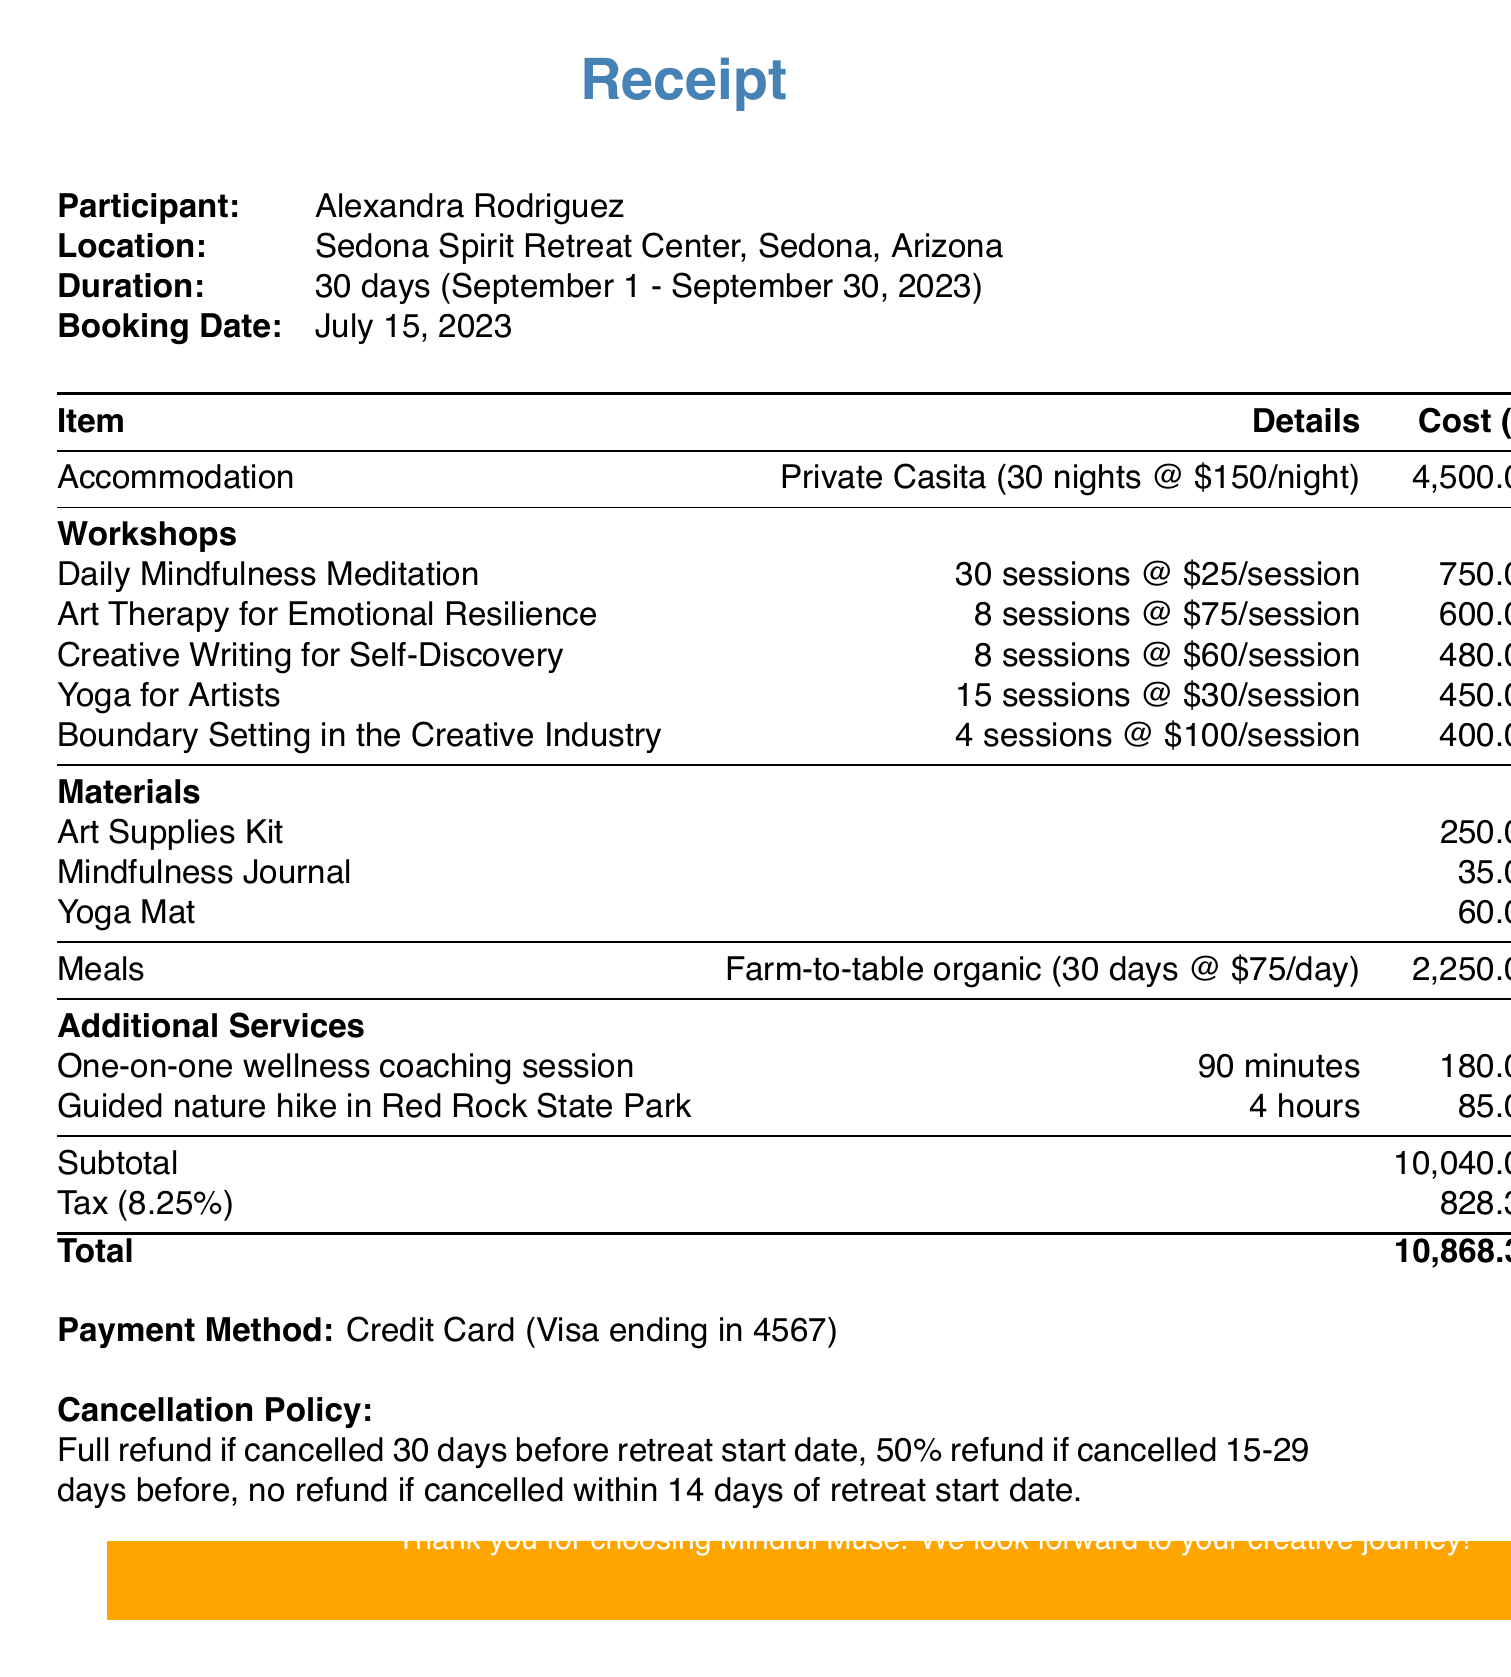What is the name of the retreat? The name of the retreat is listed at the top of the receipt, which is "Mindful Muse: Creative Rejuvenation Retreat."
Answer: Mindful Muse: Creative Rejuvenation Retreat Who is the participant? The participant's name is provided in the document, which is "Alexandra Rodriguez."
Answer: Alexandra Rodriguez What is the total cost of accommodation? The total cost of accommodation for the retreat is detailed in the receipt as "$4,500.00."
Answer: 4500.00 How many sessions are included in the Daily Mindfulness Meditation workshop? The document lists that there are "30 sessions" for the Daily Mindfulness Meditation workshop.
Answer: 30 What is the cost of the Art Therapy for Emotional Resilience workshop? The cost for the Art Therapy for Emotional Resilience workshop is mentioned as "$600.00."
Answer: 600.00 What is the tax rate applied to the subtotal? The tax rate on the subtotal is specified as "8.25%."
Answer: 8.25% What is the booking date? The booking date is clearly stated in the document as "July 15, 2023."
Answer: July 15, 2023 What is the cancellation policy? The cancellation policy details are outlined, mentioning various refund conditions relative to the cancellation date.
Answer: Full refund if cancelled 30 days before retreat start date What kind of meals are provided? The meals description specifies "Farm-to-table organic meals."
Answer: Farm-to-table organic meals Who provides the guided nature hike service? The guided nature hike service provider is named as "John Davis, Certified Nature Guide."
Answer: John Davis, Certified Nature Guide 